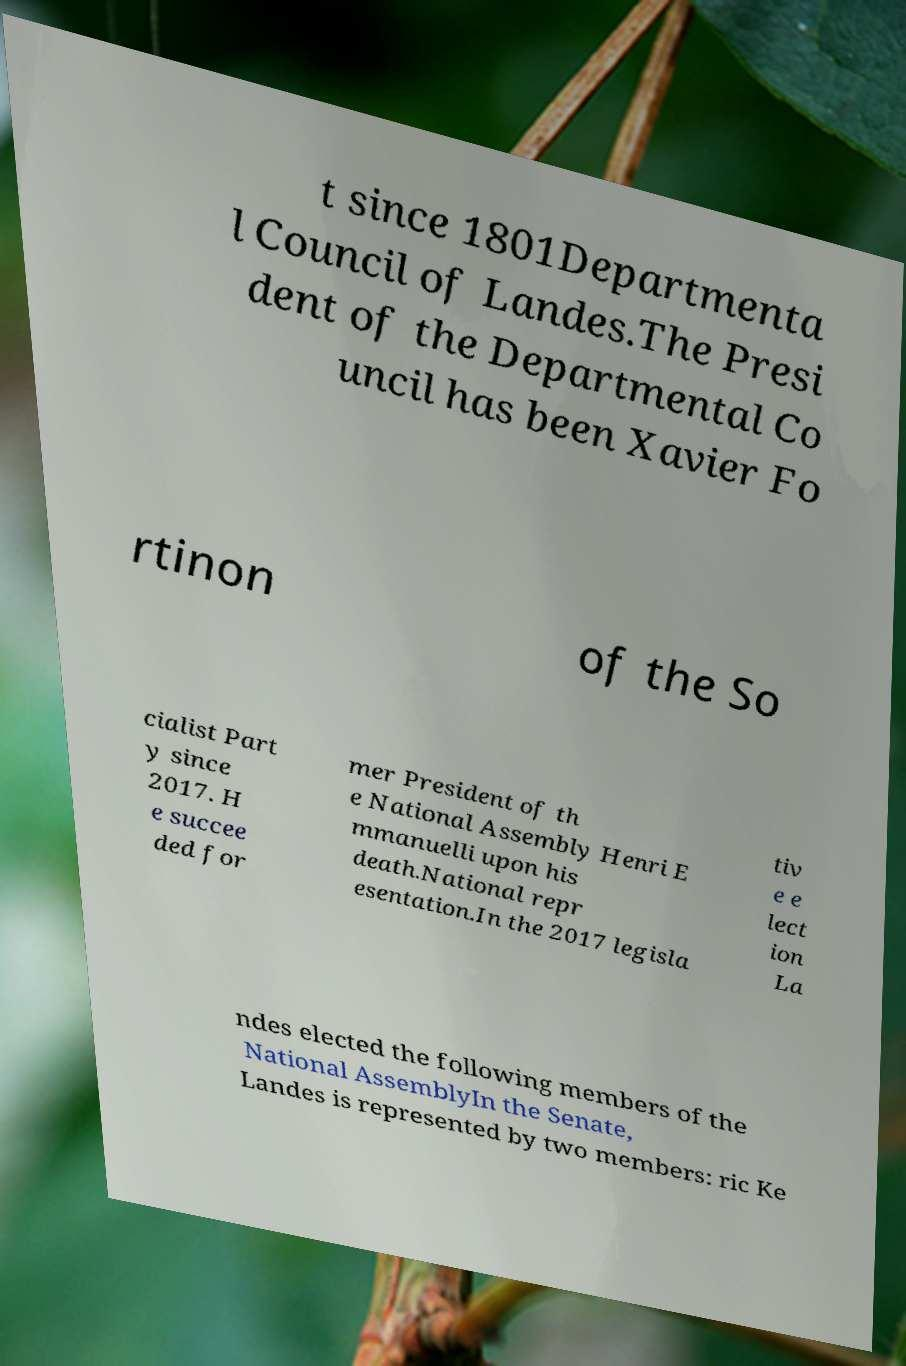Could you assist in decoding the text presented in this image and type it out clearly? t since 1801Departmenta l Council of Landes.The Presi dent of the Departmental Co uncil has been Xavier Fo rtinon of the So cialist Part y since 2017. H e succee ded for mer President of th e National Assembly Henri E mmanuelli upon his death.National repr esentation.In the 2017 legisla tiv e e lect ion La ndes elected the following members of the National AssemblyIn the Senate, Landes is represented by two members: ric Ke 